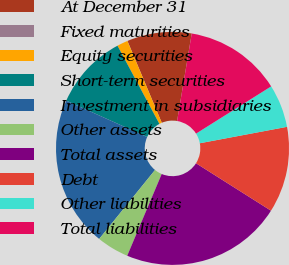Convert chart. <chart><loc_0><loc_0><loc_500><loc_500><pie_chart><fcel>At December 31<fcel>Fixed maturities<fcel>Equity securities<fcel>Short-term securities<fcel>Investment in subsidiaries<fcel>Other assets<fcel>Total assets<fcel>Debt<fcel>Other liabilities<fcel>Total liabilities<nl><fcel>8.96%<fcel>0.01%<fcel>1.5%<fcel>10.45%<fcel>20.89%<fcel>4.48%<fcel>22.38%<fcel>11.94%<fcel>5.97%<fcel>13.43%<nl></chart> 